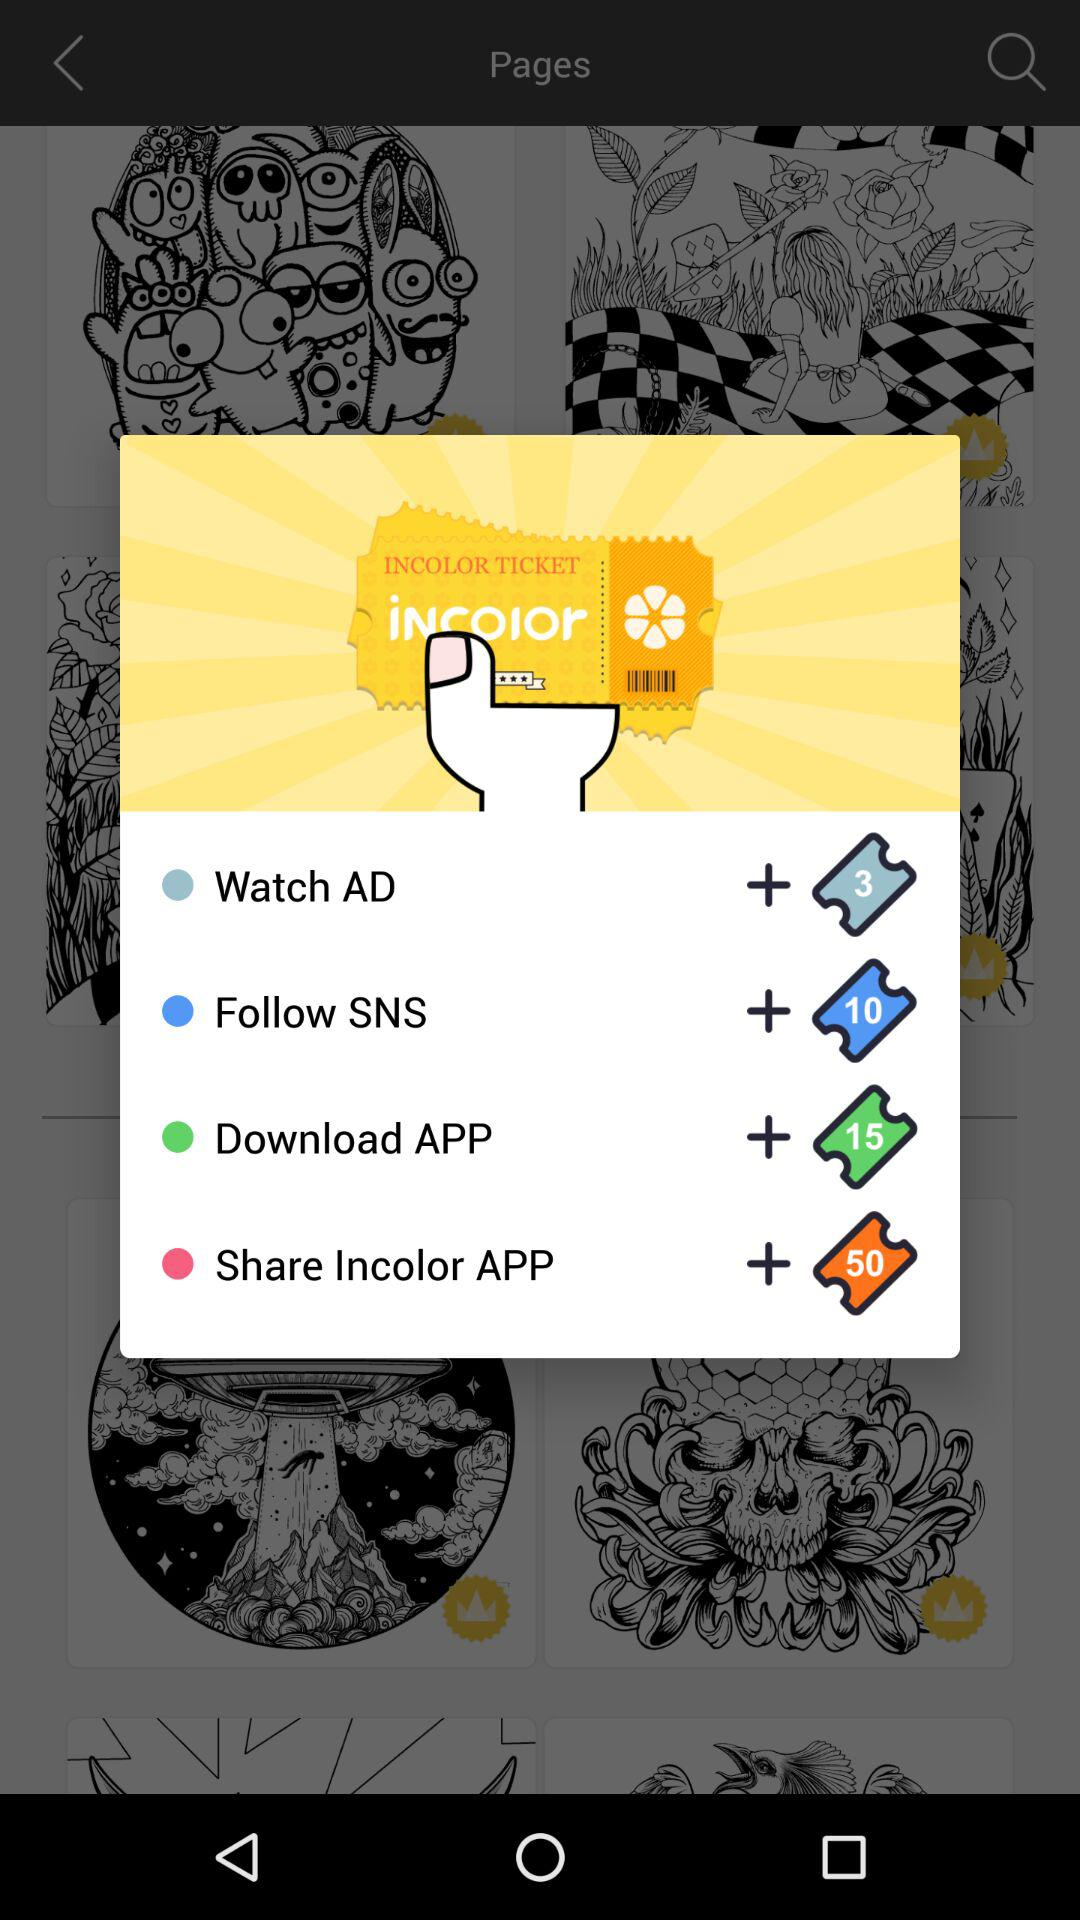What is the price for watch advertisement?
When the provided information is insufficient, respond with <no answer>. <no answer> 